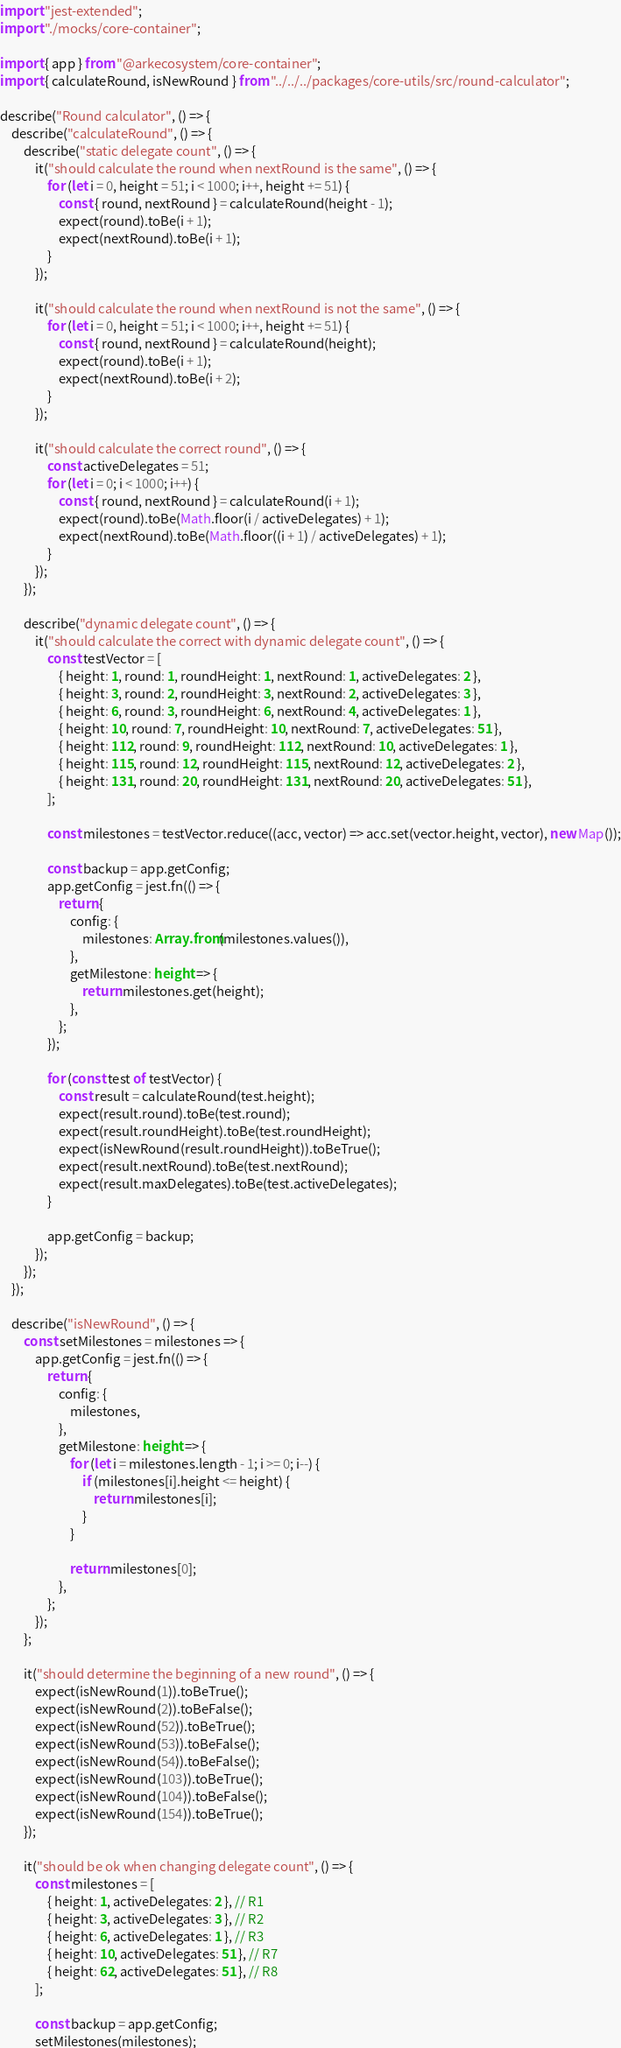Convert code to text. <code><loc_0><loc_0><loc_500><loc_500><_TypeScript_>import "jest-extended";
import "./mocks/core-container";

import { app } from "@arkecosystem/core-container";
import { calculateRound, isNewRound } from "../../../packages/core-utils/src/round-calculator";

describe("Round calculator", () => {
    describe("calculateRound", () => {
        describe("static delegate count", () => {
            it("should calculate the round when nextRound is the same", () => {
                for (let i = 0, height = 51; i < 1000; i++, height += 51) {
                    const { round, nextRound } = calculateRound(height - 1);
                    expect(round).toBe(i + 1);
                    expect(nextRound).toBe(i + 1);
                }
            });

            it("should calculate the round when nextRound is not the same", () => {
                for (let i = 0, height = 51; i < 1000; i++, height += 51) {
                    const { round, nextRound } = calculateRound(height);
                    expect(round).toBe(i + 1);
                    expect(nextRound).toBe(i + 2);
                }
            });

            it("should calculate the correct round", () => {
                const activeDelegates = 51;
                for (let i = 0; i < 1000; i++) {
                    const { round, nextRound } = calculateRound(i + 1);
                    expect(round).toBe(Math.floor(i / activeDelegates) + 1);
                    expect(nextRound).toBe(Math.floor((i + 1) / activeDelegates) + 1);
                }
            });
        });

        describe("dynamic delegate count", () => {
            it("should calculate the correct with dynamic delegate count", () => {
                const testVector = [
                    { height: 1, round: 1, roundHeight: 1, nextRound: 1, activeDelegates: 2 },
                    { height: 3, round: 2, roundHeight: 3, nextRound: 2, activeDelegates: 3 },
                    { height: 6, round: 3, roundHeight: 6, nextRound: 4, activeDelegates: 1 },
                    { height: 10, round: 7, roundHeight: 10, nextRound: 7, activeDelegates: 51 },
                    { height: 112, round: 9, roundHeight: 112, nextRound: 10, activeDelegates: 1 },
                    { height: 115, round: 12, roundHeight: 115, nextRound: 12, activeDelegates: 2 },
                    { height: 131, round: 20, roundHeight: 131, nextRound: 20, activeDelegates: 51 },
                ];

                const milestones = testVector.reduce((acc, vector) => acc.set(vector.height, vector), new Map());

                const backup = app.getConfig;
                app.getConfig = jest.fn(() => {
                    return {
                        config: {
                            milestones: Array.from(milestones.values()),
                        },
                        getMilestone: height => {
                            return milestones.get(height);
                        },
                    };
                });

                for (const test of testVector) {
                    const result = calculateRound(test.height);
                    expect(result.round).toBe(test.round);
                    expect(result.roundHeight).toBe(test.roundHeight);
                    expect(isNewRound(result.roundHeight)).toBeTrue();
                    expect(result.nextRound).toBe(test.nextRound);
                    expect(result.maxDelegates).toBe(test.activeDelegates);
                }

                app.getConfig = backup;
            });
        });
    });

    describe("isNewRound", () => {
        const setMilestones = milestones => {
            app.getConfig = jest.fn(() => {
                return {
                    config: {
                        milestones,
                    },
                    getMilestone: height => {
                        for (let i = milestones.length - 1; i >= 0; i--) {
                            if (milestones[i].height <= height) {
                                return milestones[i];
                            }
                        }

                        return milestones[0];
                    },
                };
            });
        };

        it("should determine the beginning of a new round", () => {
            expect(isNewRound(1)).toBeTrue();
            expect(isNewRound(2)).toBeFalse();
            expect(isNewRound(52)).toBeTrue();
            expect(isNewRound(53)).toBeFalse();
            expect(isNewRound(54)).toBeFalse();
            expect(isNewRound(103)).toBeTrue();
            expect(isNewRound(104)).toBeFalse();
            expect(isNewRound(154)).toBeTrue();
        });

        it("should be ok when changing delegate count", () => {
            const milestones = [
                { height: 1, activeDelegates: 2 }, // R1
                { height: 3, activeDelegates: 3 }, // R2
                { height: 6, activeDelegates: 1 }, // R3
                { height: 10, activeDelegates: 51 }, // R7
                { height: 62, activeDelegates: 51 }, // R8
            ];

            const backup = app.getConfig;
            setMilestones(milestones);
</code> 